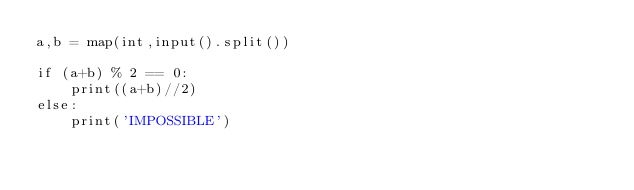<code> <loc_0><loc_0><loc_500><loc_500><_Python_>a,b = map(int,input().split())

if (a+b) % 2 == 0:
    print((a+b)//2)
else:
    print('IMPOSSIBLE')</code> 